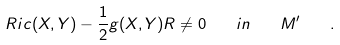<formula> <loc_0><loc_0><loc_500><loc_500>R i c ( X , Y ) - \frac { 1 } { 2 } g ( X , Y ) R \not = 0 \quad i n \quad M ^ { \prime } \quad .</formula> 